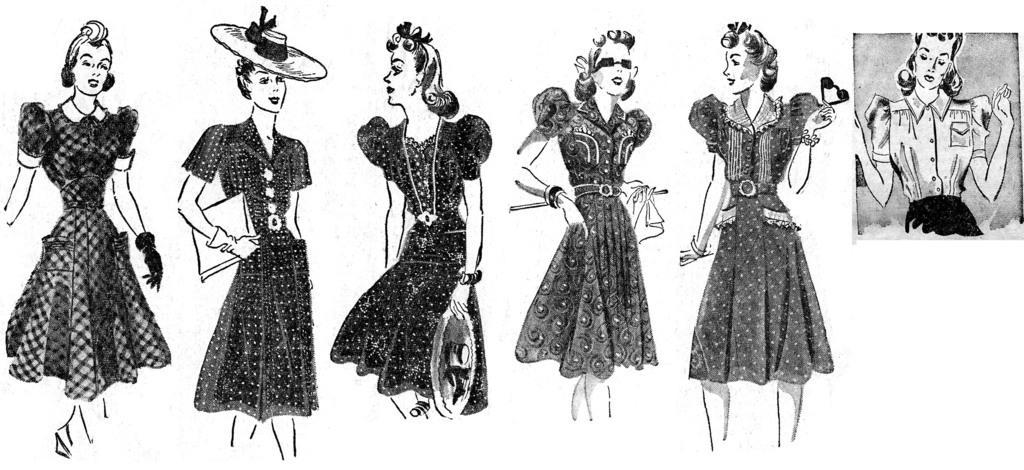In one or two sentences, can you explain what this image depicts? In this image we can see drawings of girls. 